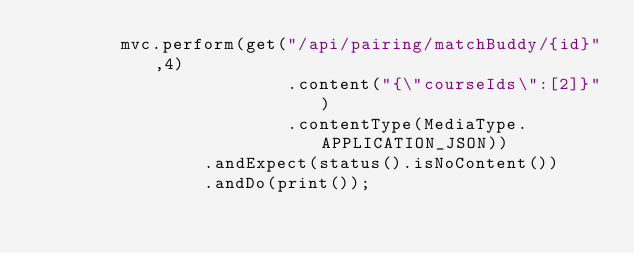<code> <loc_0><loc_0><loc_500><loc_500><_Java_>        mvc.perform(get("/api/pairing/matchBuddy/{id}",4)
                        .content("{\"courseIds\":[2]}")
                        .contentType(MediaType.APPLICATION_JSON))
                .andExpect(status().isNoContent())
                .andDo(print());</code> 